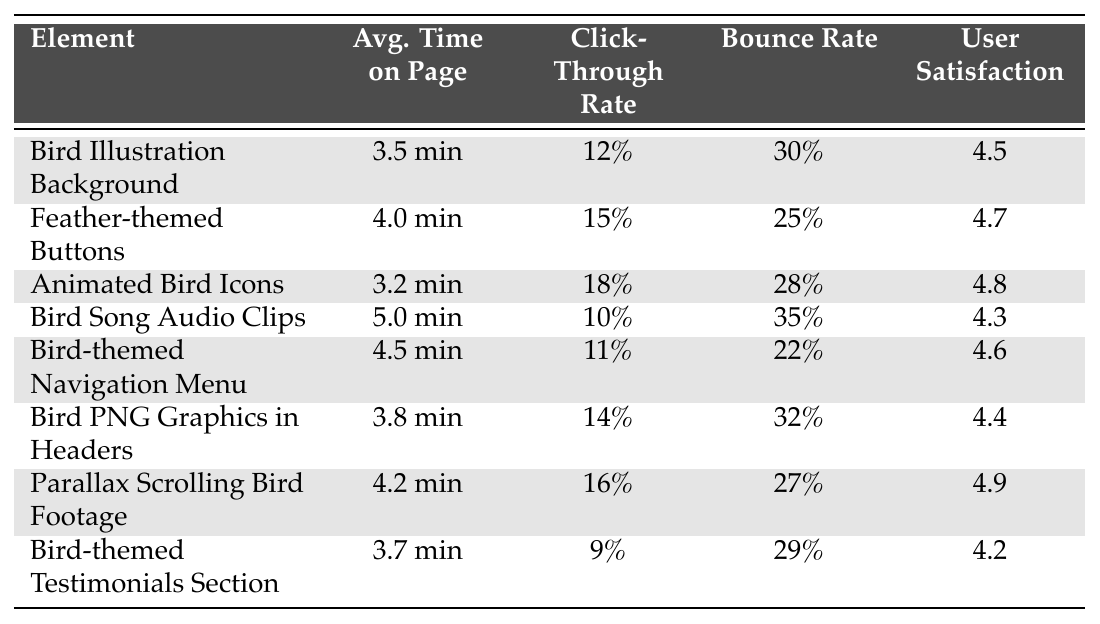What is the user satisfaction rating for Feather-themed Buttons? The user satisfaction rating for Feather-themed Buttons is listed directly in the table under the corresponding element, which shows a rating of 4.7.
Answer: 4.7 Which element has the highest average time on page? By examining the 'Avg. Time on Page' column, we see that the Bird Song Audio Clips have the highest value at 5.0 minutes.
Answer: 5.0 minutes What is the click-through rate for animated bird icons? The click-through rate for Animated Bird Icons is given in the table, showing a value of 18%.
Answer: 18% Which element has the lowest click-through rate? Reviewing the table's click-through rates, Bird-themed Testimonials Section has the lowest rate at 9%.
Answer: 9% What is the average user satisfaction rating of all bird-themed web design elements? To find the average, first sum all user satisfaction ratings: 4.5 + 4.7 + 4.8 + 4.3 + 4.6 + 4.4 + 4.9 + 4.2 = 36.4. There are 8 elements, so divide by 8, which gives 36.4 / 8 = 4.55.
Answer: 4.55 Is the bounce rate for Feather-themed Buttons lower than the bounce rate for Bird PNG Graphics in Headers? Looking at the respective bounce rates, Feather-themed Buttons has 25%, while Bird PNG Graphics in Headers shows 32%. Since 25% is less than 32%, the answer is yes.
Answer: Yes What is the difference in bounce rate between the Bird Illustration Background and the Bird-themed Navigation Menu? The bounce rate for Bird Illustration Background is 30%, and for Bird-themed Navigation Menu, it is 22%. The difference is 30% - 22% = 8%.
Answer: 8% Is the average time on page for all elements greater than 4 minutes? Calculate the sum of average times: 3.5 + 4.0 + 3.2 + 5.0 + 4.5 + 3.8 + 4.2 + 3.7 = 32.9. Since there are 8 elements, average = 32.9 / 8 = 4.1125, which is greater than 4 minutes.
Answer: Yes How many elements have a user satisfaction rating above 4.5? Looking through the user satisfaction ratings in the table, the elements with ratings above 4.5 are Feather-themed Buttons (4.7), Animated Bird Icons (4.8), and Parallax Scrolling Bird Footage (4.9). There are 3 elements.
Answer: 3 Which element has the best combination of click-through rate and user satisfaction? To determine the best combination, consider both the click-through rate and user satisfaction. Parallax Scrolling Bird Footage has a high click-through rate (16%) and the highest user satisfaction (4.9), which makes it the best overall combination.
Answer: Parallax Scrolling Bird Footage 